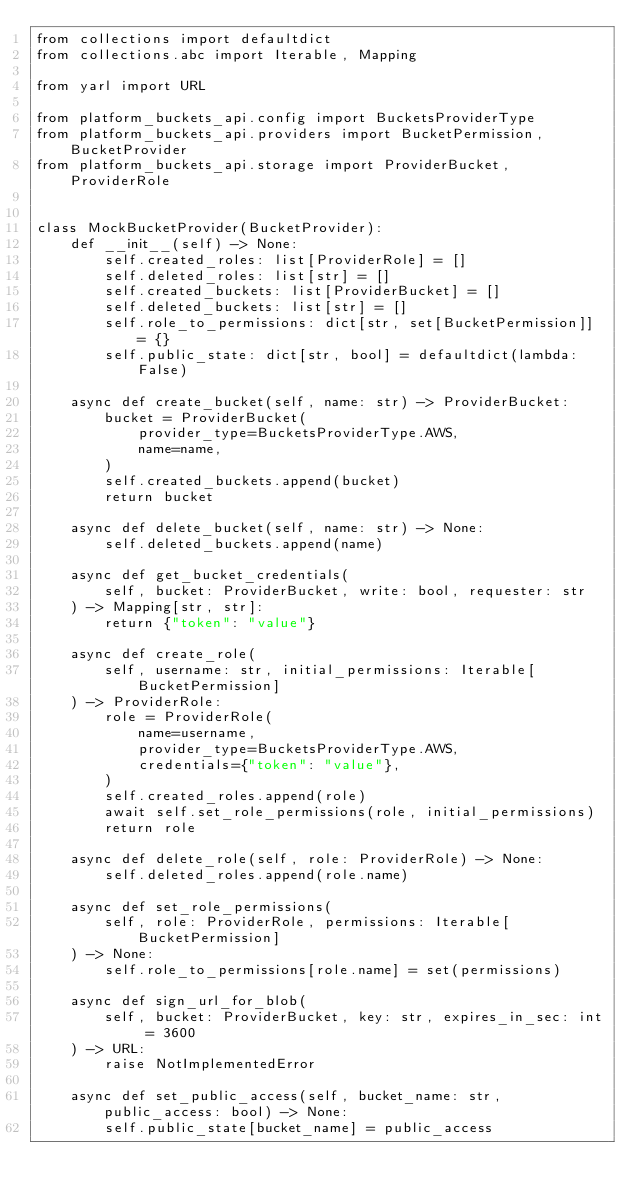Convert code to text. <code><loc_0><loc_0><loc_500><loc_500><_Python_>from collections import defaultdict
from collections.abc import Iterable, Mapping

from yarl import URL

from platform_buckets_api.config import BucketsProviderType
from platform_buckets_api.providers import BucketPermission, BucketProvider
from platform_buckets_api.storage import ProviderBucket, ProviderRole


class MockBucketProvider(BucketProvider):
    def __init__(self) -> None:
        self.created_roles: list[ProviderRole] = []
        self.deleted_roles: list[str] = []
        self.created_buckets: list[ProviderBucket] = []
        self.deleted_buckets: list[str] = []
        self.role_to_permissions: dict[str, set[BucketPermission]] = {}
        self.public_state: dict[str, bool] = defaultdict(lambda: False)

    async def create_bucket(self, name: str) -> ProviderBucket:
        bucket = ProviderBucket(
            provider_type=BucketsProviderType.AWS,
            name=name,
        )
        self.created_buckets.append(bucket)
        return bucket

    async def delete_bucket(self, name: str) -> None:
        self.deleted_buckets.append(name)

    async def get_bucket_credentials(
        self, bucket: ProviderBucket, write: bool, requester: str
    ) -> Mapping[str, str]:
        return {"token": "value"}

    async def create_role(
        self, username: str, initial_permissions: Iterable[BucketPermission]
    ) -> ProviderRole:
        role = ProviderRole(
            name=username,
            provider_type=BucketsProviderType.AWS,
            credentials={"token": "value"},
        )
        self.created_roles.append(role)
        await self.set_role_permissions(role, initial_permissions)
        return role

    async def delete_role(self, role: ProviderRole) -> None:
        self.deleted_roles.append(role.name)

    async def set_role_permissions(
        self, role: ProviderRole, permissions: Iterable[BucketPermission]
    ) -> None:
        self.role_to_permissions[role.name] = set(permissions)

    async def sign_url_for_blob(
        self, bucket: ProviderBucket, key: str, expires_in_sec: int = 3600
    ) -> URL:
        raise NotImplementedError

    async def set_public_access(self, bucket_name: str, public_access: bool) -> None:
        self.public_state[bucket_name] = public_access
</code> 